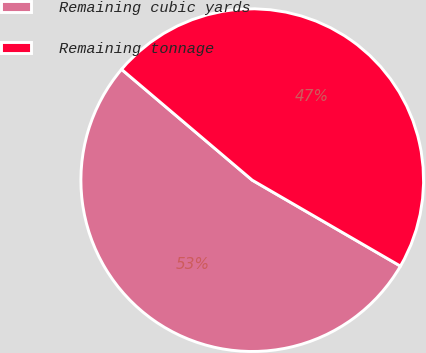Convert chart. <chart><loc_0><loc_0><loc_500><loc_500><pie_chart><fcel>Remaining cubic yards<fcel>Remaining tonnage<nl><fcel>52.83%<fcel>47.17%<nl></chart> 